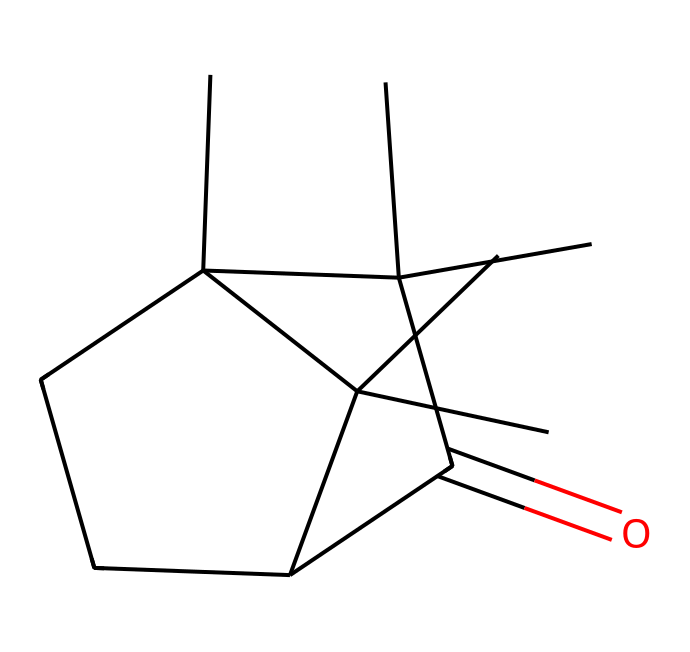What is the name of this chemical? Looking at the SMILES representation and its molecular structure, the compound is identified as camphor, which is a well-known organic compound historically used as a solvent.
Answer: camphor How many carbon atoms are in the structure? By analyzing the SMILES representation, we can count the number of carbon atoms present. The structure reveals 10 carbon atoms in total.
Answer: 10 What functional group is present in camphor? The presence of the carbonyl group (C=O) is identified in the structure, indicating that camphor contains a ketone functional group.
Answer: ketone What is the molecular formula of camphor? From the SMILES, we can derive the molecular formula by counting the different atoms. Camphor has the molecular formula C10H16O.
Answer: C10H16O Is camphor polar or nonpolar? Given its molecular structure, which contains a polar functional group (the carbonyl), but primarily comprises a nonpolar hydrocarbon backbone, camphor is classified as nonpolar overall.
Answer: nonpolar How does the cyclic structure of camphor affect its volatility? The cyclic structure of camphor contributes to its relatively low boiling point and high volatility, as it allows for less steric hindrance compared to larger, non-cyclized molecules.
Answer: high volatility What is a common historical use of camphor as a solvent? Historically, camphor was commonly used in the extraction of aromatic compounds due to its solvent properties, aiding the study of natural substances.
Answer: extraction of aromatic compounds 